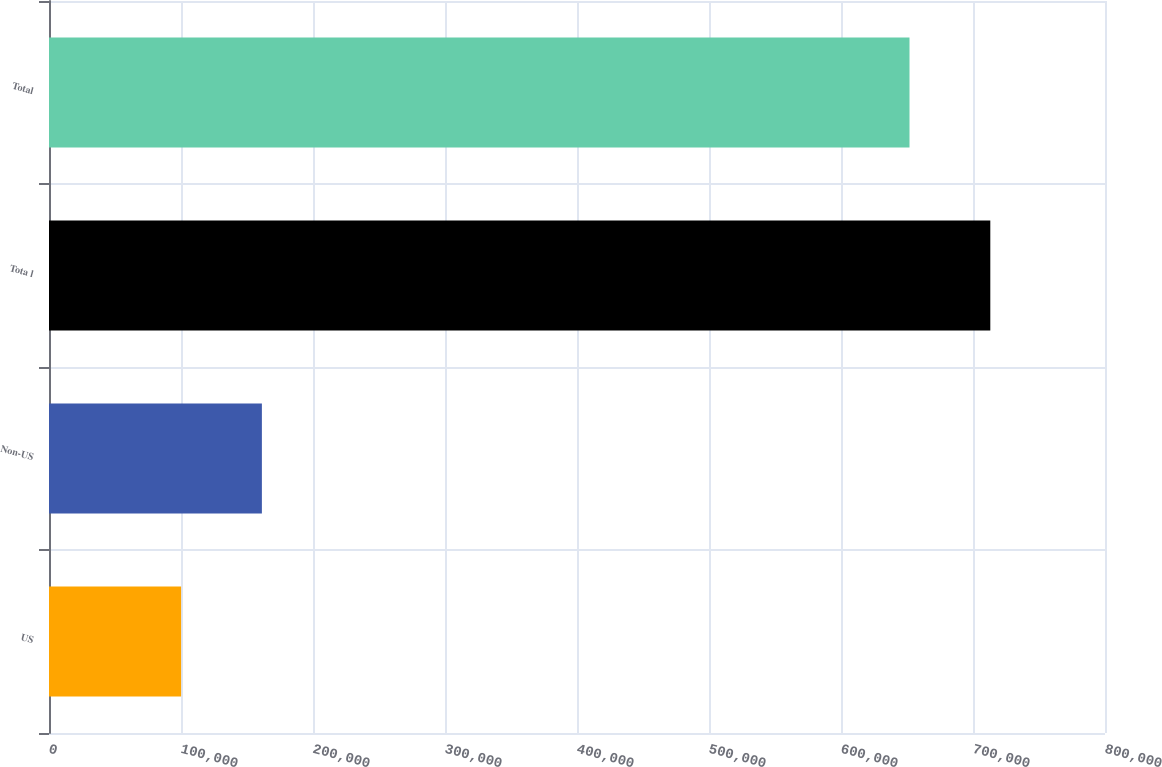<chart> <loc_0><loc_0><loc_500><loc_500><bar_chart><fcel>US<fcel>Non-US<fcel>Tota l<fcel>Total<nl><fcel>100066<fcel>161277<fcel>713108<fcel>651897<nl></chart> 